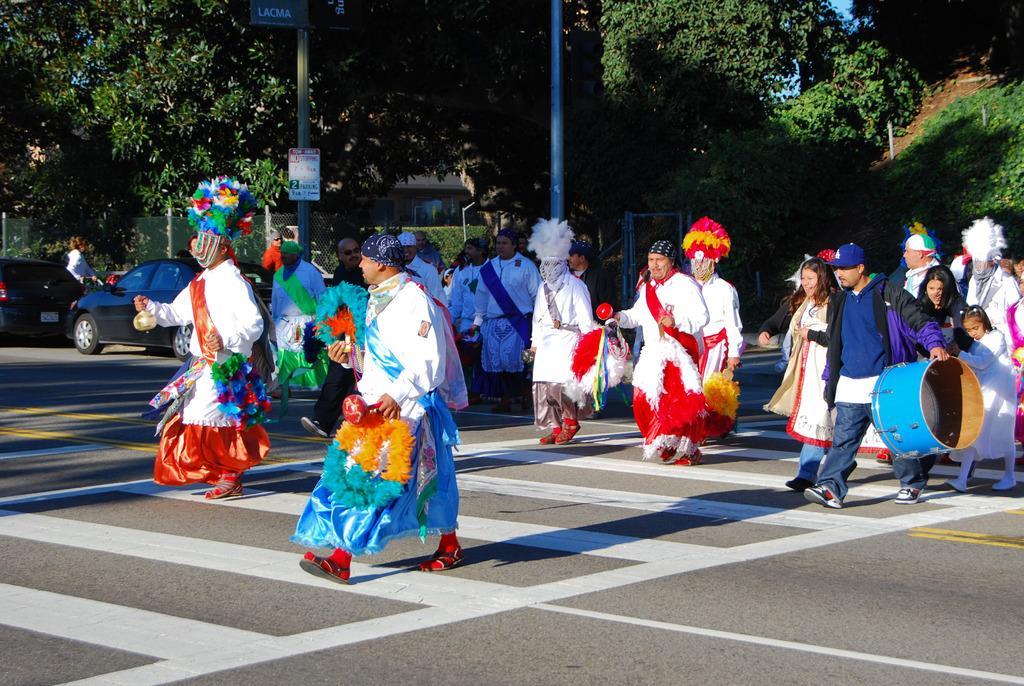How would you summarize this image in a sentence or two? In the image,there are group of people walking on the road. They are wearing different costumes and behind these people there are two cars and around the road there are many trees. 